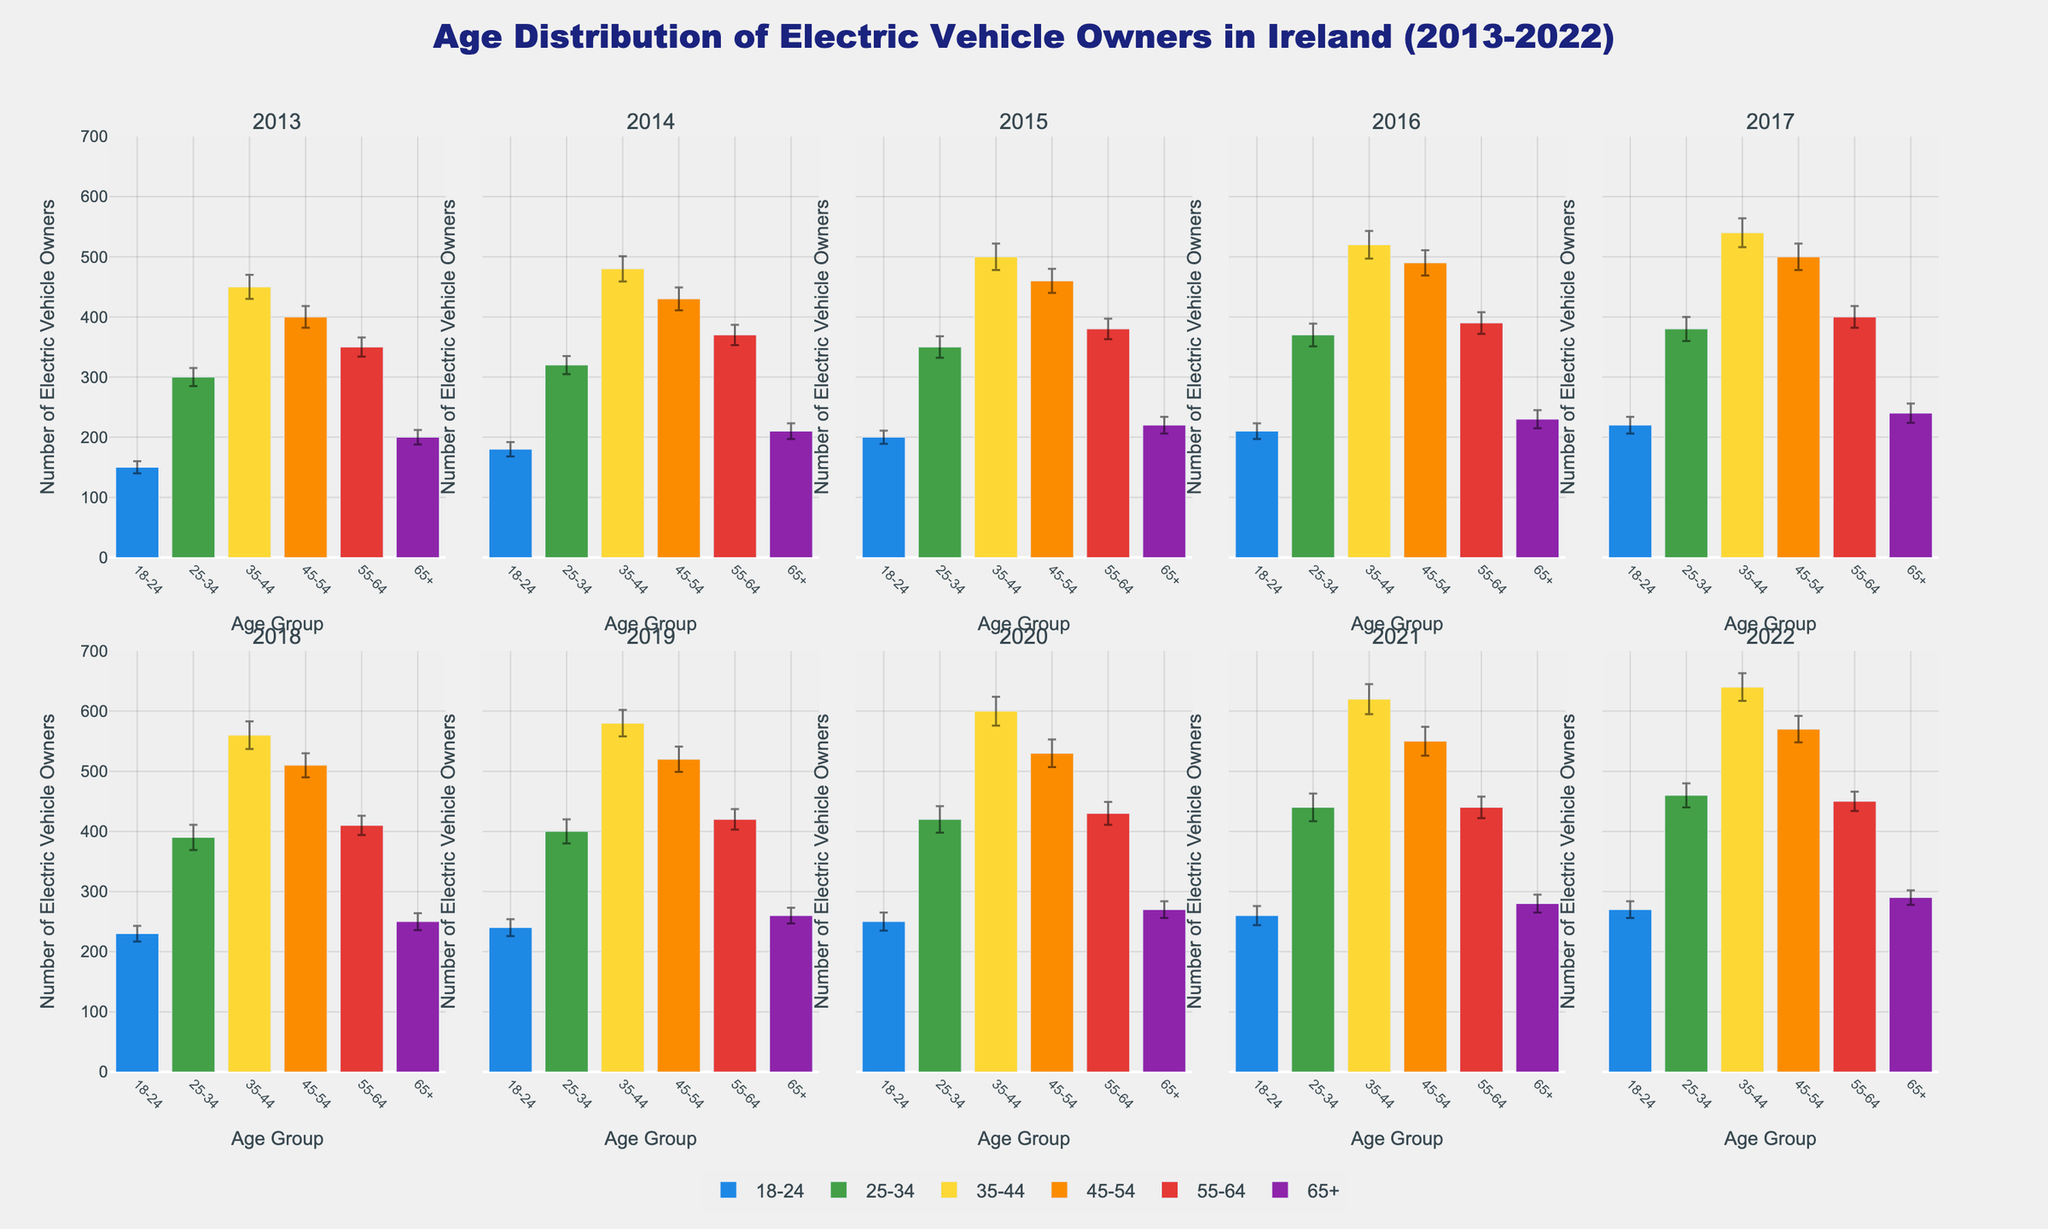What's the title of the figure? The title of the figure is written at the top center and describes the main content of the visualization. In this case, it reads "Age Distribution of Electric Vehicle Owners in Ireland (2013-2022)"
Answer: Age Distribution of Electric Vehicle Owners in Ireland (2013-2022) Which age group had the most electric vehicle owners in 2017? In the subplot for 2017, the bar representing the age group 35-44 is the highest, indicating that this age group had the most electric vehicle owners in that year.
Answer: 35-44 How did the number of electric vehicle owners in the 18-24 age group change from 2013 to 2022? By comparing the bar height of the 18-24 age group in the subplots for 2013 and 2022, we see an increase from 150 in 2013 to 270 in 2022.
Answer: Increased In which year did the 45-54 age group have the highest number of electric vehicle owners? Looking through the subplots, the bar for the 45-54 age group is highest in 2022 at 570.
Answer: 2022 Which age group showed the least variation in the number of electric vehicle owners over the years? By visually comparing the length and consistency of the error bars across all years for each age group, the 65+ group shows the least variation.
Answer: 65+ Are there any age groups whose number of electric vehicle owners consistently increased every year? By examining each subplot in sequence for every age group, the 65+ group consistently shows an increase from 2013 to 2022.
Answer: 65+ What was the total number of electric vehicle owners in the 35-44 age group over the decade? Sum the number of owners from the 35-44 age group for each year: 450 + 480 + 500 + 520 + 540 + 560 + 580 + 600 + 620 + 640 = 5490.
Answer: 5490 In which year did the 25-34 age group have the lowest number of electric vehicle owners? Scanning through each subplot, the bar for the 25-34 age group is shortest in 2013 at 300.
Answer: 2013 How do the error bars for the 55-64 age group in 2020 compare to 2022? The error bars for the 55-64 age group in 2020 and 2022 are visibly larger in 2020, indicating higher variability (19 in 2020 vs. 16 in 2022).
Answer: Larger in 2020 